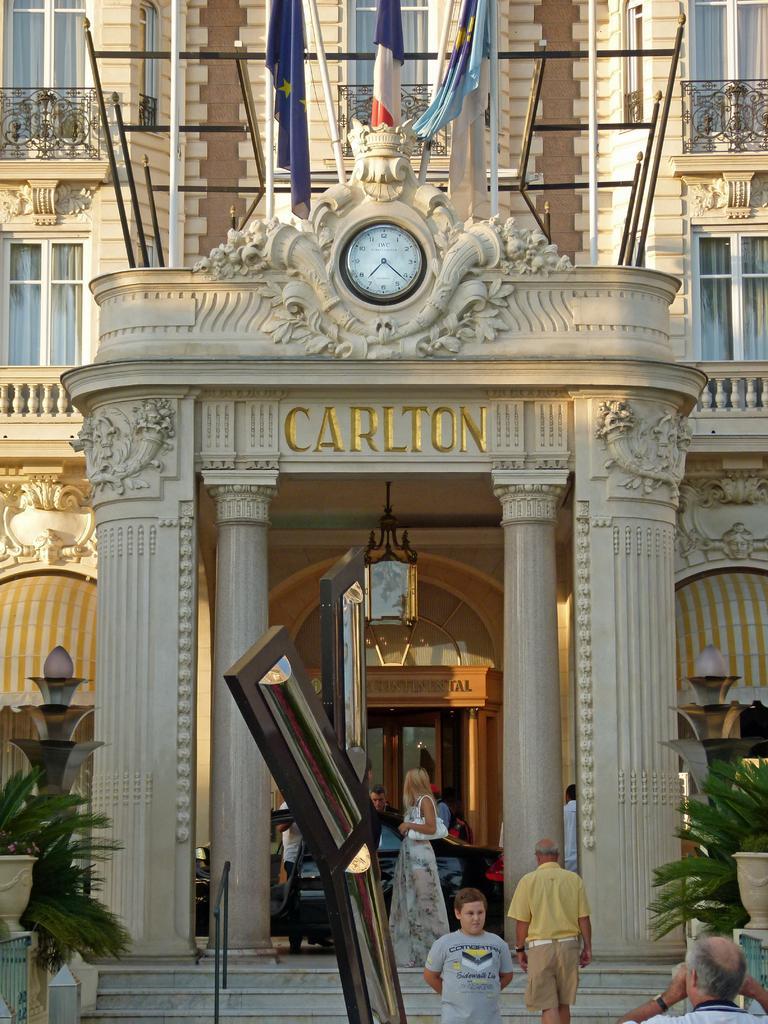Could you give a brief overview of what you see in this image? In this image I can see the group of people with different color dresses. On both sides of these people I can see the plants and the lights. In the background I can see the building with windows, flags, railing and the clock. 